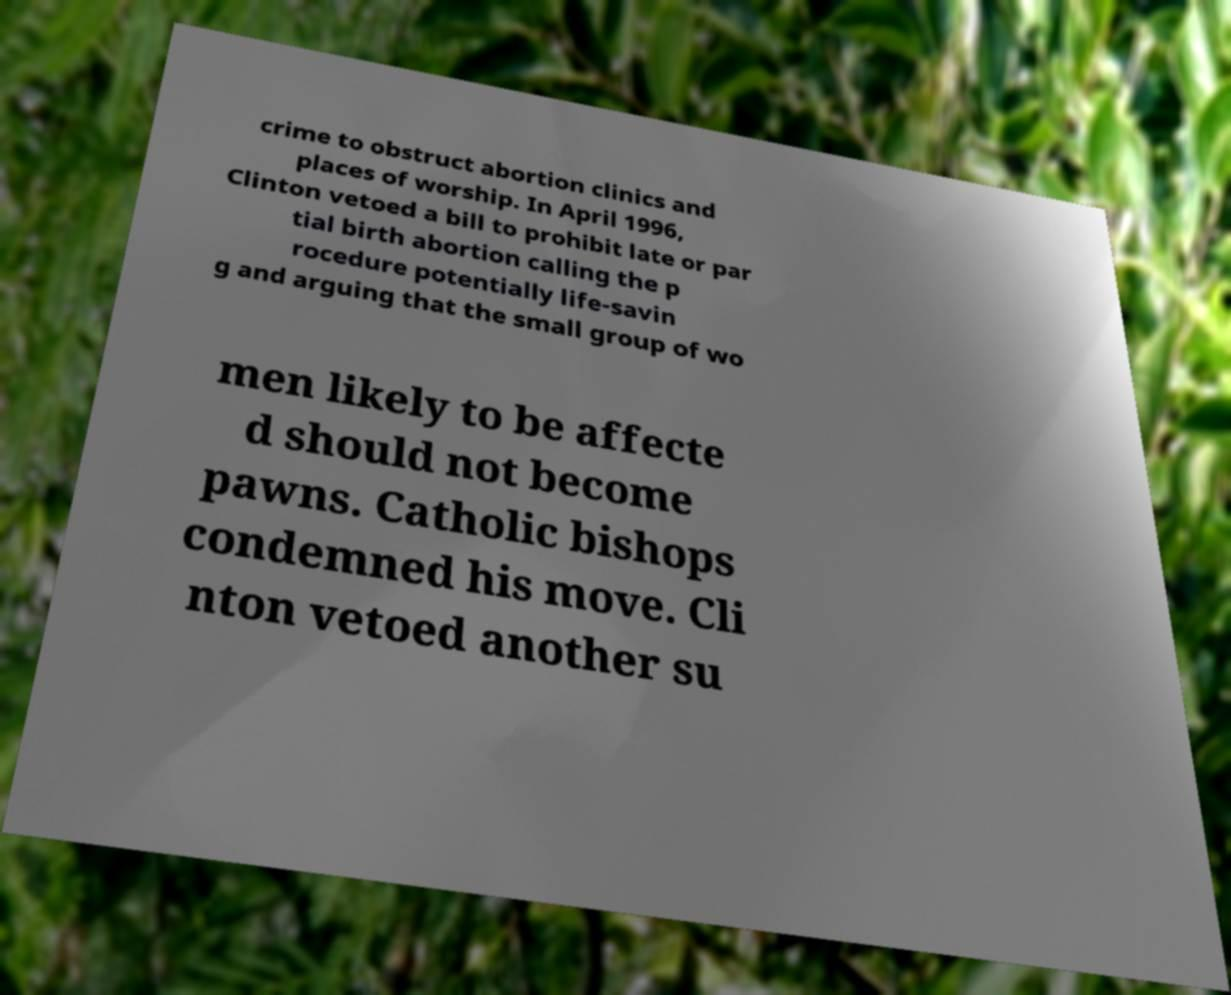What messages or text are displayed in this image? I need them in a readable, typed format. crime to obstruct abortion clinics and places of worship. In April 1996, Clinton vetoed a bill to prohibit late or par tial birth abortion calling the p rocedure potentially life-savin g and arguing that the small group of wo men likely to be affecte d should not become pawns. Catholic bishops condemned his move. Cli nton vetoed another su 